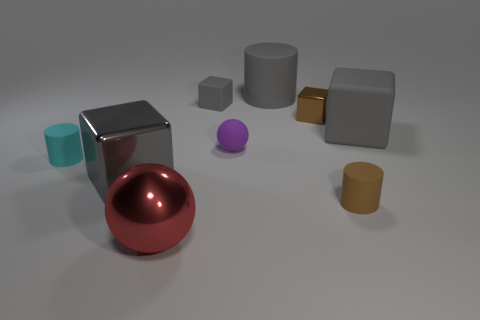Subtract all green cylinders. How many gray cubes are left? 3 Subtract 1 cubes. How many cubes are left? 3 Subtract all small cylinders. How many cylinders are left? 1 Add 1 small yellow cylinders. How many objects exist? 10 Subtract all brown cubes. How many cubes are left? 3 Subtract all blue blocks. Subtract all green balls. How many blocks are left? 4 Subtract all blocks. How many objects are left? 5 Subtract all big cyan shiny blocks. Subtract all big gray metallic objects. How many objects are left? 8 Add 5 small gray cubes. How many small gray cubes are left? 6 Add 1 purple matte things. How many purple matte things exist? 2 